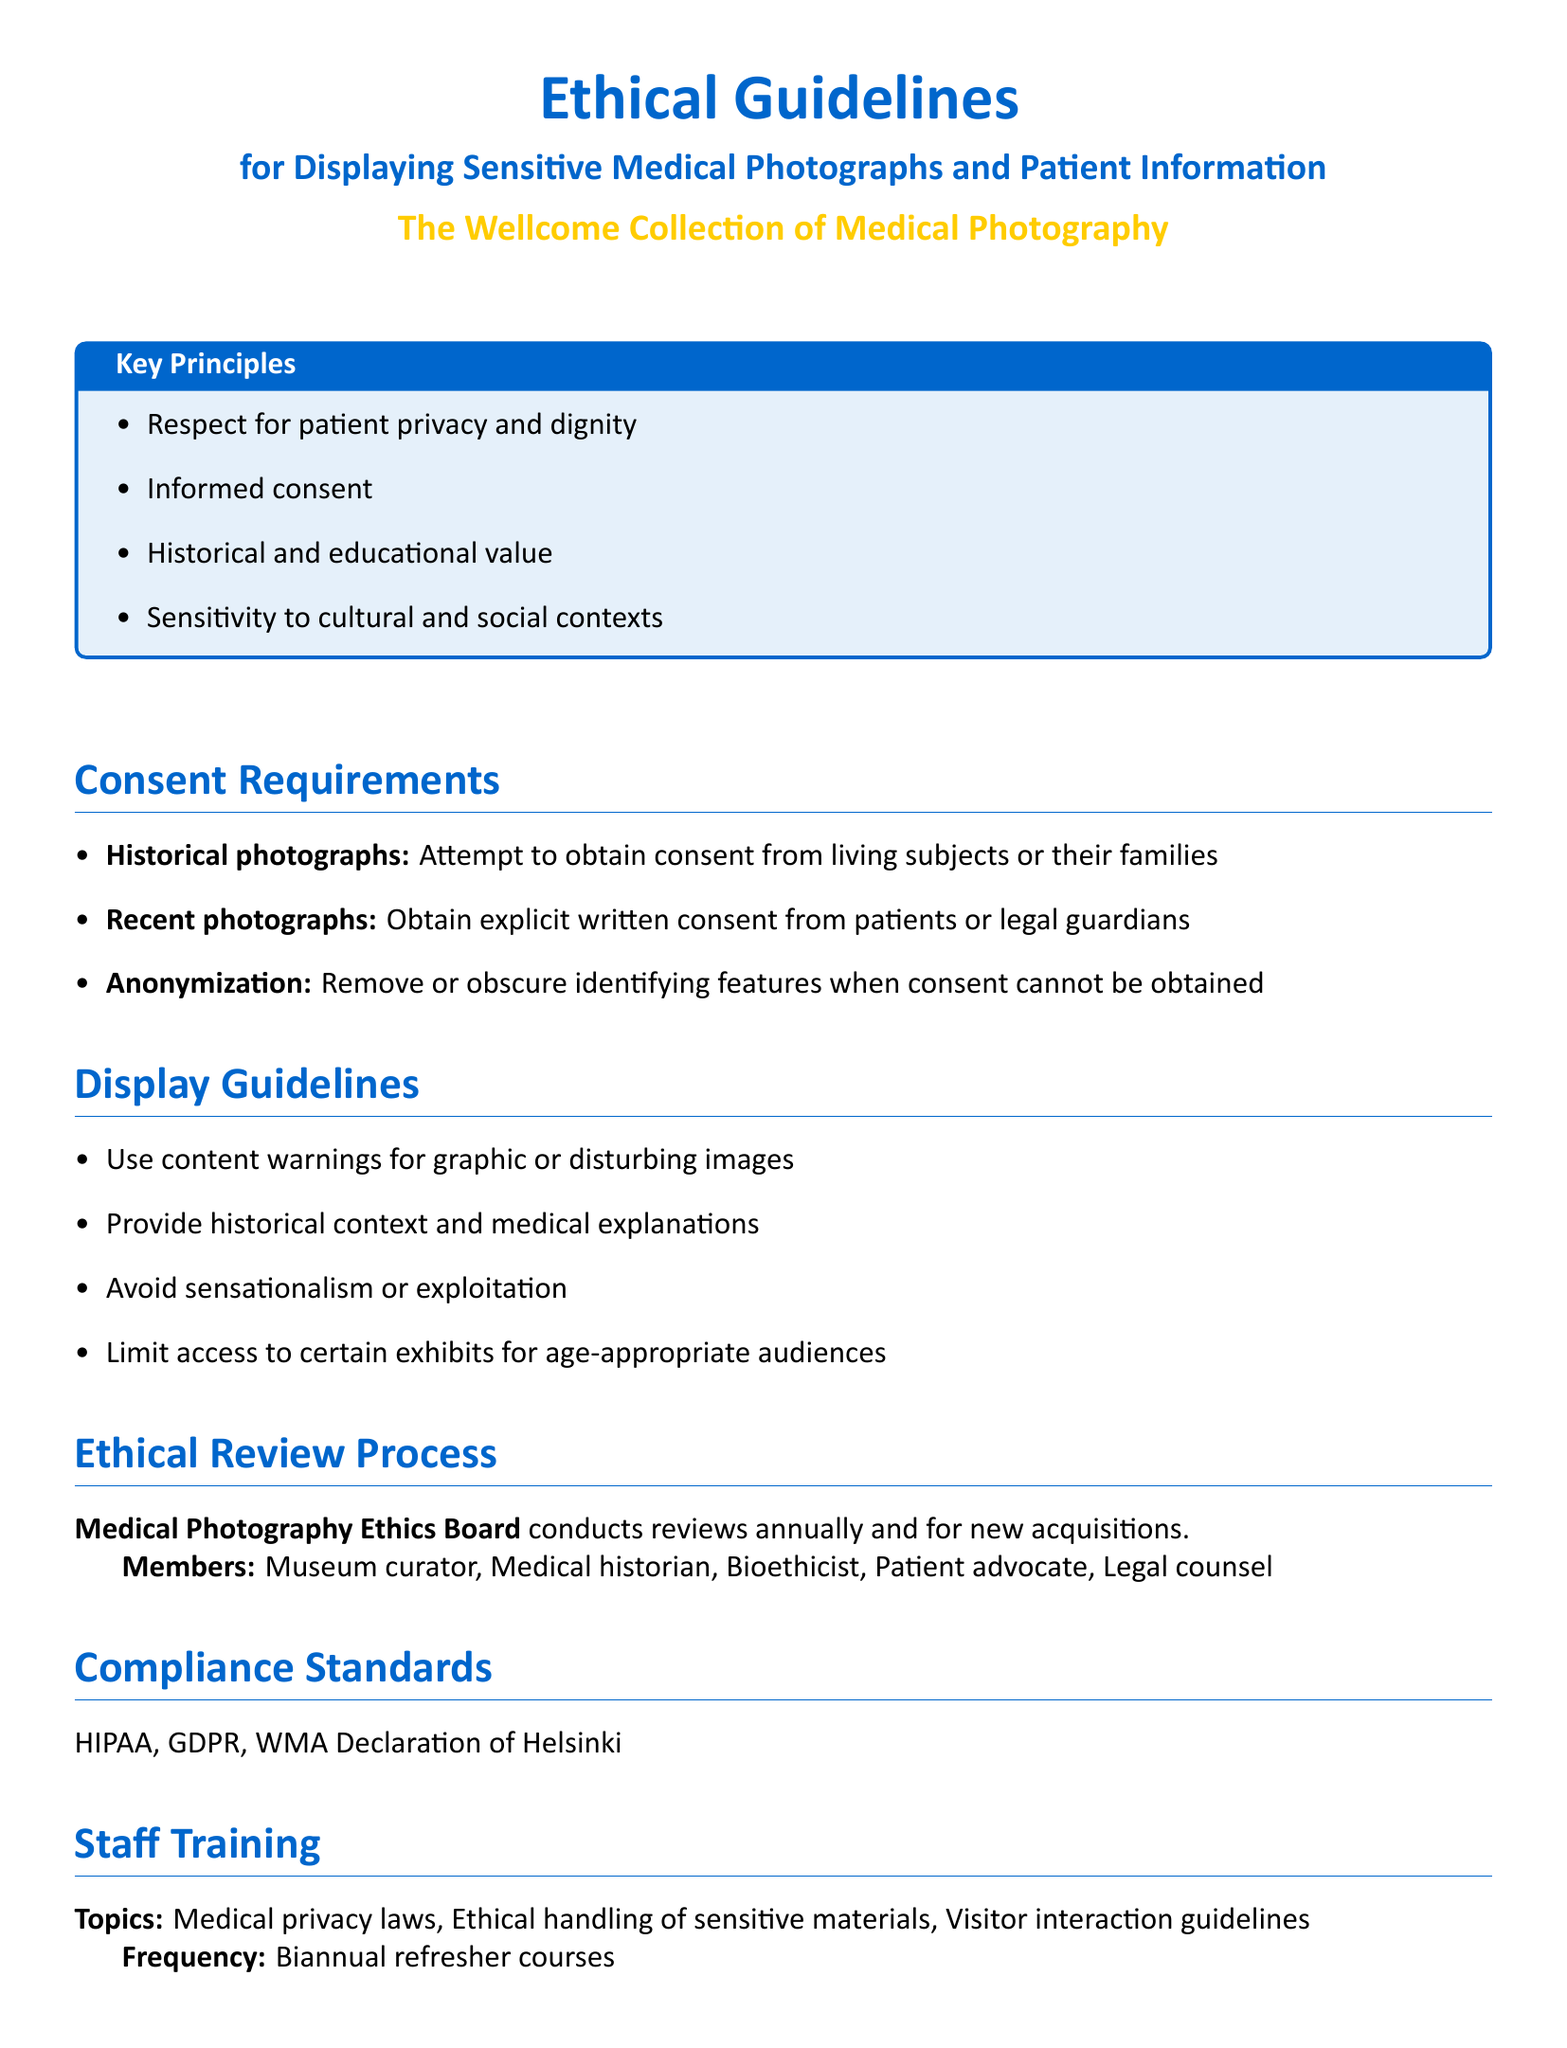What are the key principles outlined in the document? The key principles are listed in a box and include respect for patient privacy and dignity, informed consent, historical and educational value, and sensitivity to cultural and social contexts.
Answer: Respect for patient privacy and dignity, informed consent, historical and educational value, sensitivity to cultural and social contexts What is required for historical photographs? The section on consent requirements indicates that for historical photographs, an attempt should be made to obtain consent from living subjects or their families.
Answer: Attempt to obtain consent from living subjects or their families Who conducts the ethical review process? The ethical review process is conducted by the Medical Photography Ethics Board, which includes various members such as the museum curator and medical historian.
Answer: Medical Photography Ethics Board How often are staff training sessions held? The document states that staff training is conducted biannually, which is every six months.
Answer: Biannual What should be provided with graphic or disturbing images? The document specifies that content warnings should be used for graphic or disturbing images to prepare visitors.
Answer: Content warnings What is the primary purpose of the guidelines? The guidelines are intended for ethical handling of sensitive medical photographs and patient information, ensuring respect and compliance with various standards.
Answer: Ethical handling of sensitive medical photographs and patient information Who are the members of the Medical Photography Ethics Board? Members of the board include the museum curator, medical historian, bioethicist, patient advocate, and legal counsel.
Answer: Museum curator, Medical historian, Bioethicist, Patient advocate, Legal counsel What do compliance standards include? The compliance standards mentioned in the document include HIPAA, GDPR, and WMA Declaration of Helsinki.
Answer: HIPAA, GDPR, WMA Declaration of Helsinki 